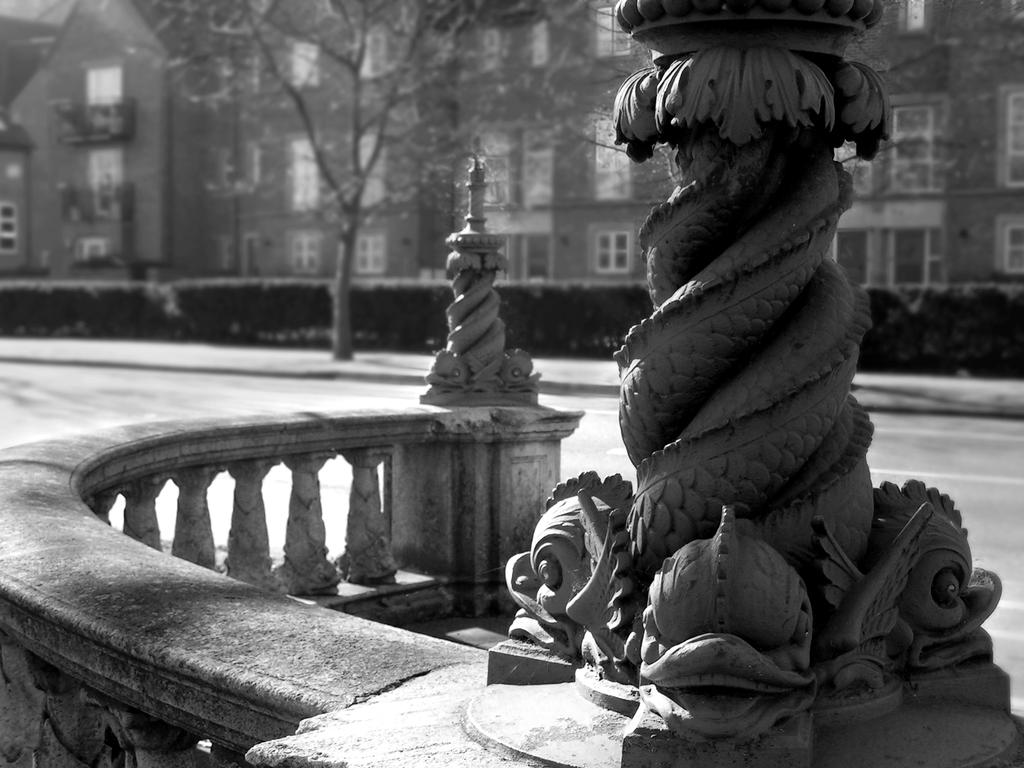What is the color scheme of the image? The image is black and white. What is the main subject in the image? There is a statue in the image. What is blocking the path in the image? There is a barricade in the image. What can be seen in the distance in the image? There is a road, a group of plants, trees, and a building with windows visible in the background of the image. How many books are being touched by the statue in the image? There are no books present in the image, and the statue is not interacting with any books. What page of the book is the statue reading in the image? There is no book or page visible in the image, as it features a statue, a barricade, and various background elements. 